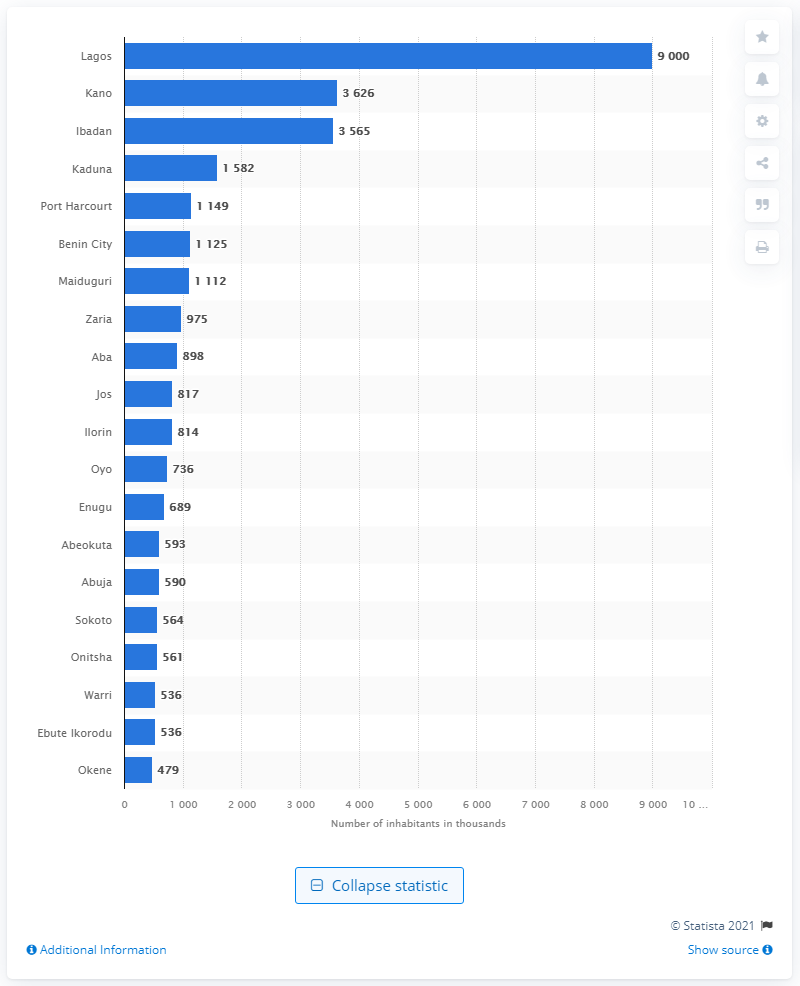Draw attention to some important aspects in this diagram. In Nigeria, Lagos is the largest city. Kano is the second largest city in Nigeria. Lagos is the main financial, cultural, and educational center of Nigeria. 